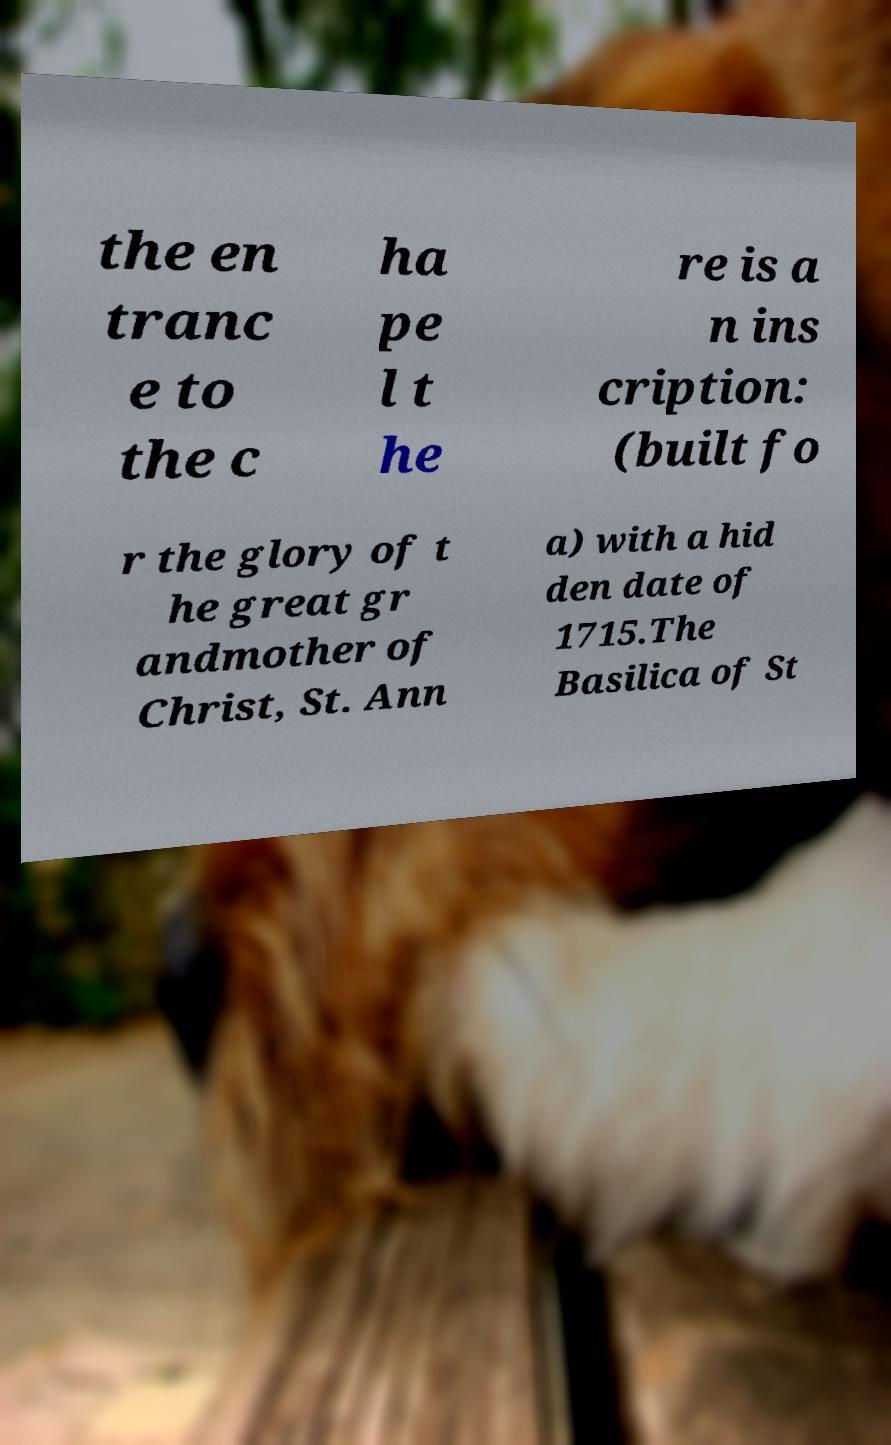Please identify and transcribe the text found in this image. the en tranc e to the c ha pe l t he re is a n ins cription: (built fo r the glory of t he great gr andmother of Christ, St. Ann a) with a hid den date of 1715.The Basilica of St 